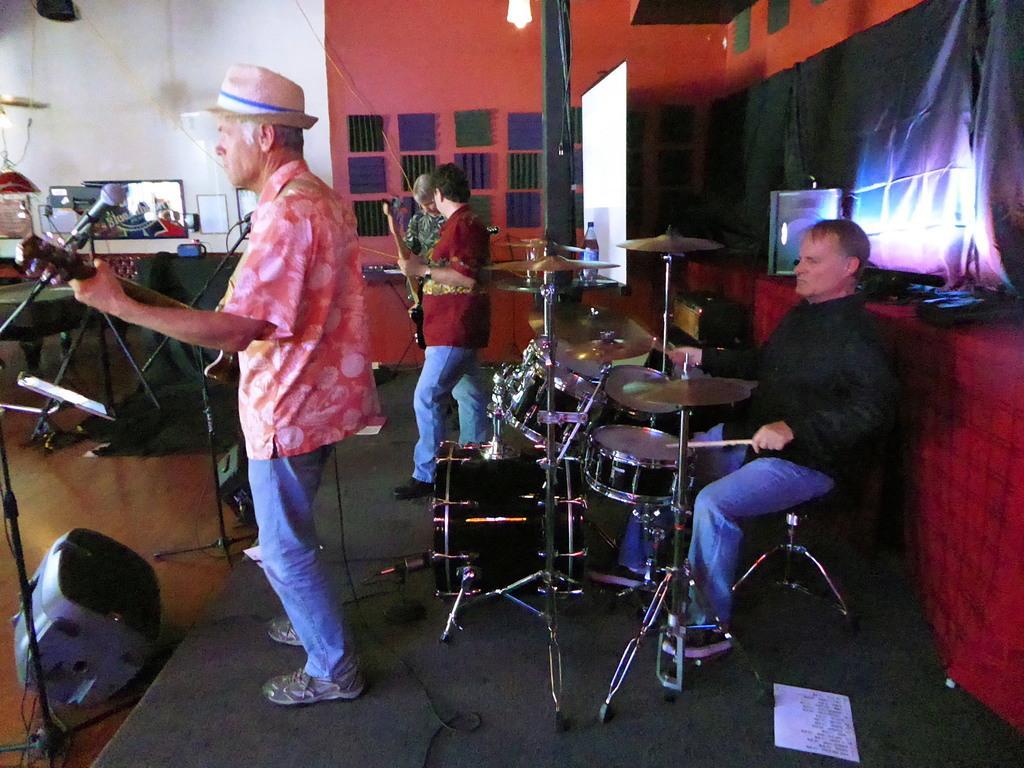Could you give a brief overview of what you see in this image? In this image we can see some group of persons playing musical instruments, there are sound boxes and at the background of the image there is wall and some colorful sheets are attached to the wall. 